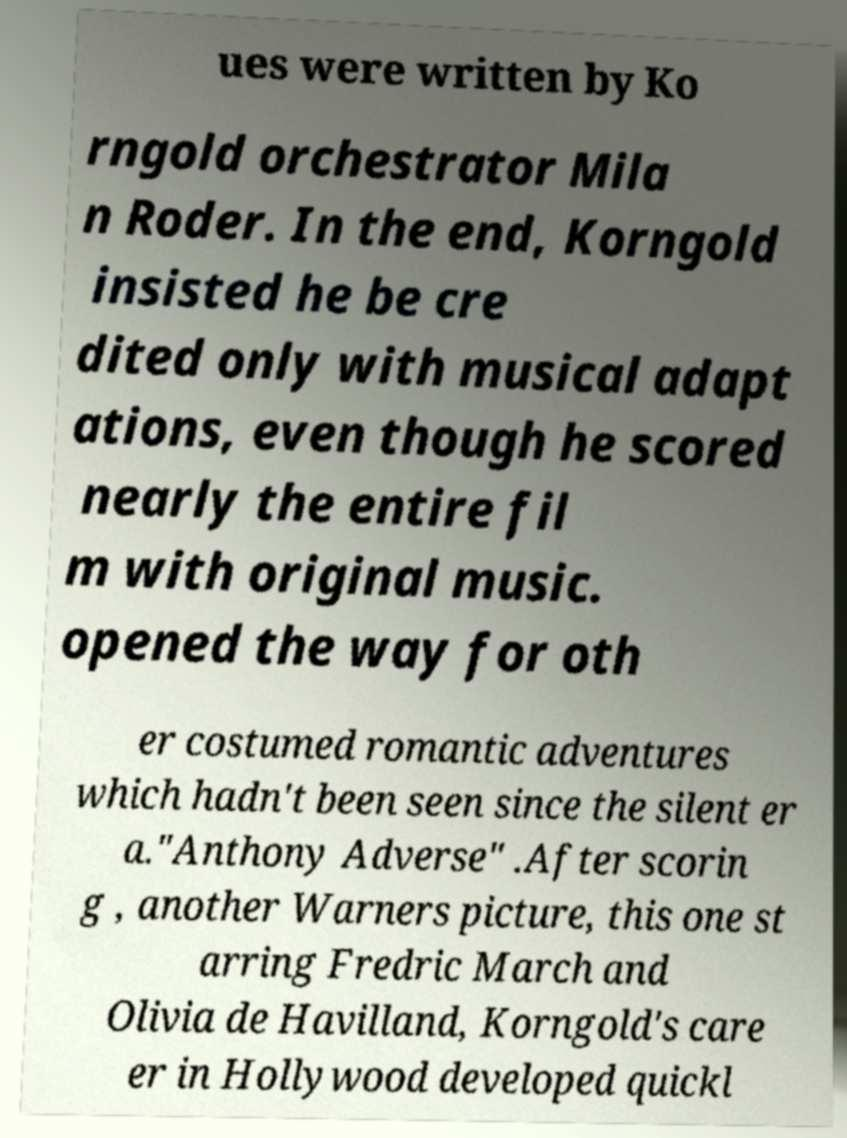Could you assist in decoding the text presented in this image and type it out clearly? ues were written by Ko rngold orchestrator Mila n Roder. In the end, Korngold insisted he be cre dited only with musical adapt ations, even though he scored nearly the entire fil m with original music. opened the way for oth er costumed romantic adventures which hadn't been seen since the silent er a."Anthony Adverse" .After scorin g , another Warners picture, this one st arring Fredric March and Olivia de Havilland, Korngold's care er in Hollywood developed quickl 